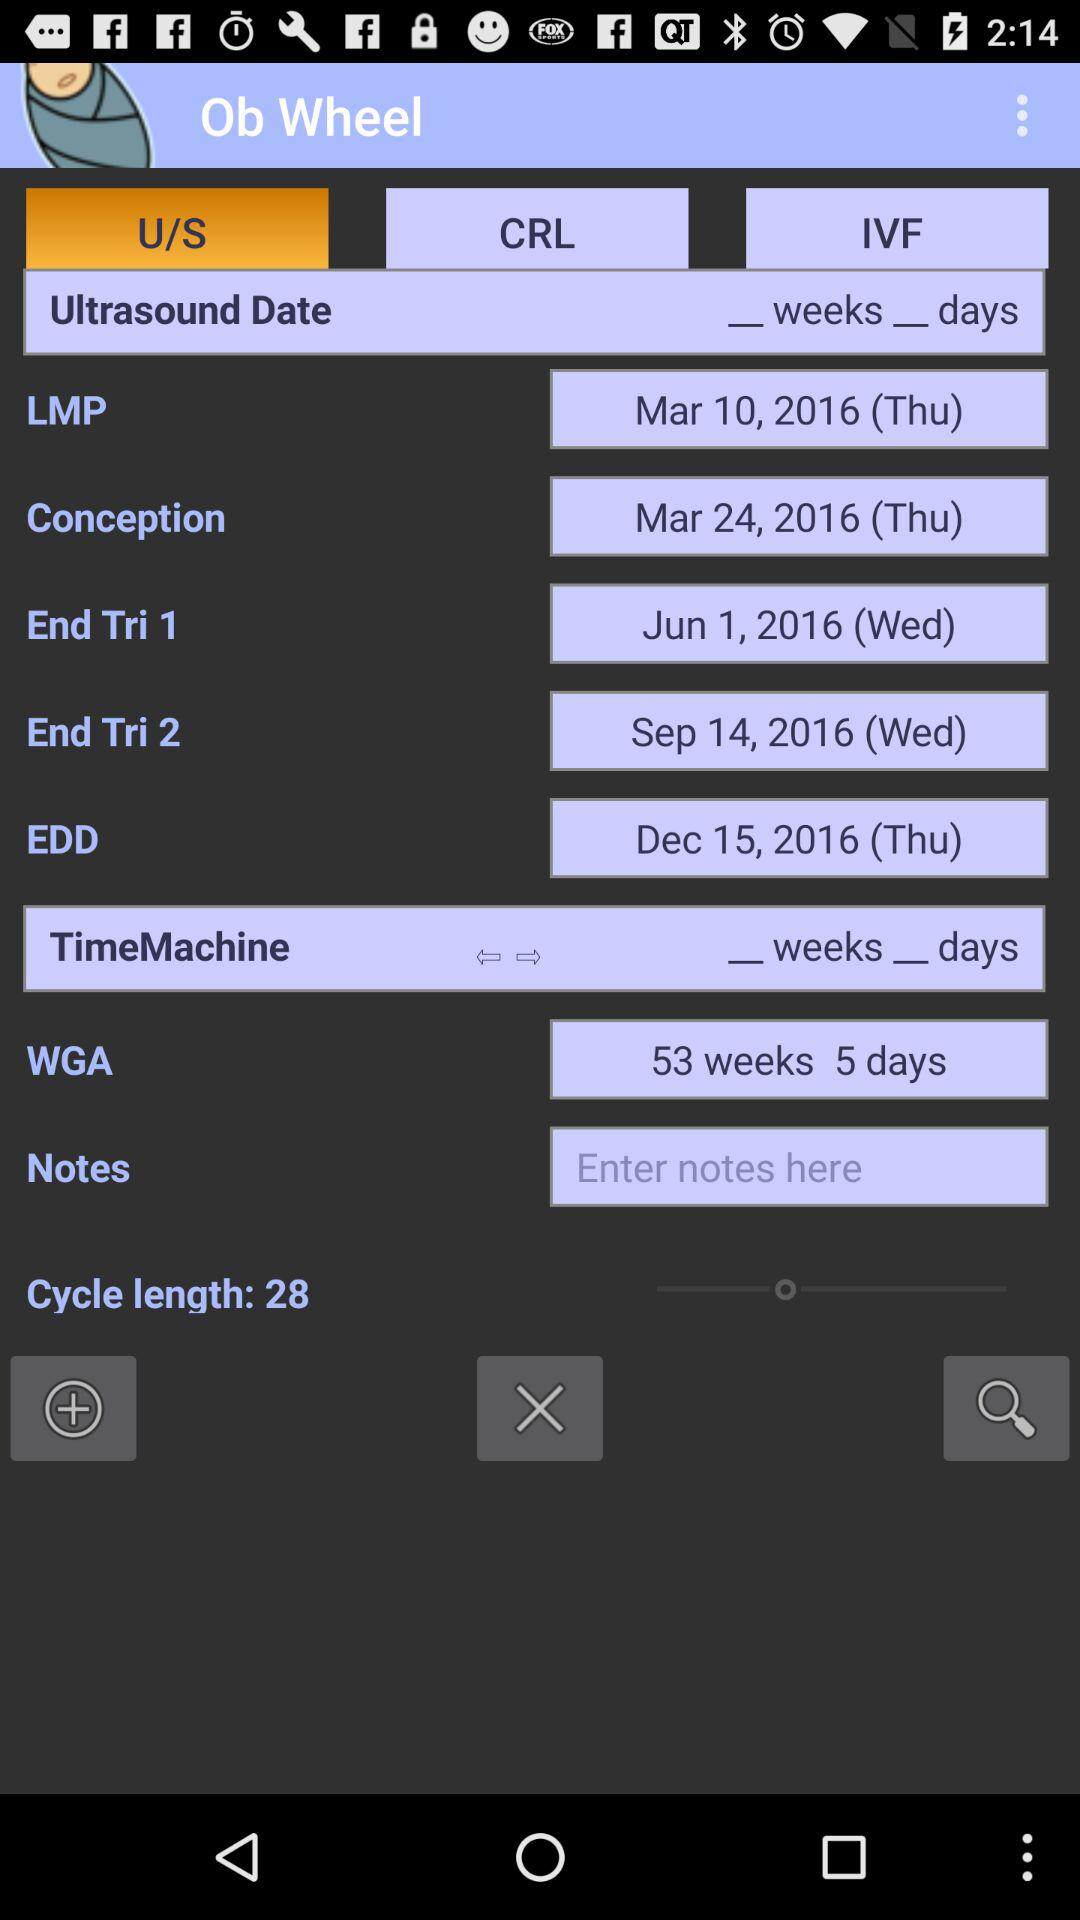What is the date of LMP? The date of LMP is Thursday, March 10, 2016. 